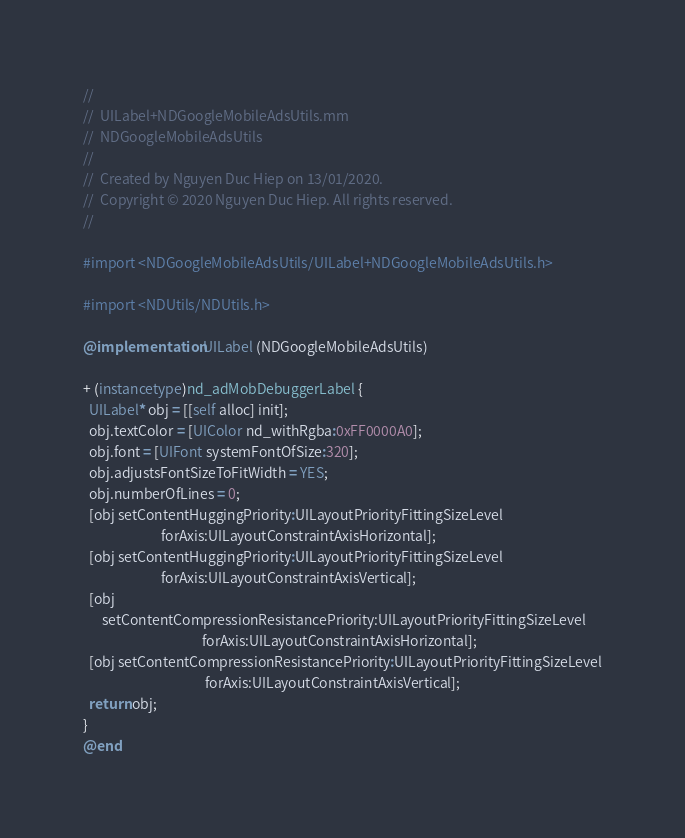<code> <loc_0><loc_0><loc_500><loc_500><_ObjectiveC_>//
//  UILabel+NDGoogleMobileAdsUtils.mm
//  NDGoogleMobileAdsUtils
//
//  Created by Nguyen Duc Hiep on 13/01/2020.
//  Copyright © 2020 Nguyen Duc Hiep. All rights reserved.
//

#import <NDGoogleMobileAdsUtils/UILabel+NDGoogleMobileAdsUtils.h>

#import <NDUtils/NDUtils.h>

@implementation UILabel (NDGoogleMobileAdsUtils)

+ (instancetype)nd_adMobDebuggerLabel {
  UILabel* obj = [[self alloc] init];
  obj.textColor = [UIColor nd_withRgba:0xFF0000A0];
  obj.font = [UIFont systemFontOfSize:320];
  obj.adjustsFontSizeToFitWidth = YES;
  obj.numberOfLines = 0;
  [obj setContentHuggingPriority:UILayoutPriorityFittingSizeLevel
                         forAxis:UILayoutConstraintAxisHorizontal];
  [obj setContentHuggingPriority:UILayoutPriorityFittingSizeLevel
                         forAxis:UILayoutConstraintAxisVertical];
  [obj
      setContentCompressionResistancePriority:UILayoutPriorityFittingSizeLevel
                                      forAxis:UILayoutConstraintAxisHorizontal];
  [obj setContentCompressionResistancePriority:UILayoutPriorityFittingSizeLevel
                                       forAxis:UILayoutConstraintAxisVertical];
  return obj;
}
@end
</code> 